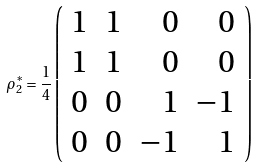Convert formula to latex. <formula><loc_0><loc_0><loc_500><loc_500>\rho _ { 2 } ^ { \ast } = \frac { 1 } { 4 } \left ( \begin{array} { c c r r } 1 & 1 & 0 & 0 \\ 1 & 1 & 0 & 0 \\ 0 & 0 & 1 & - 1 \\ 0 & 0 & - 1 & 1 \end{array} \right )</formula> 